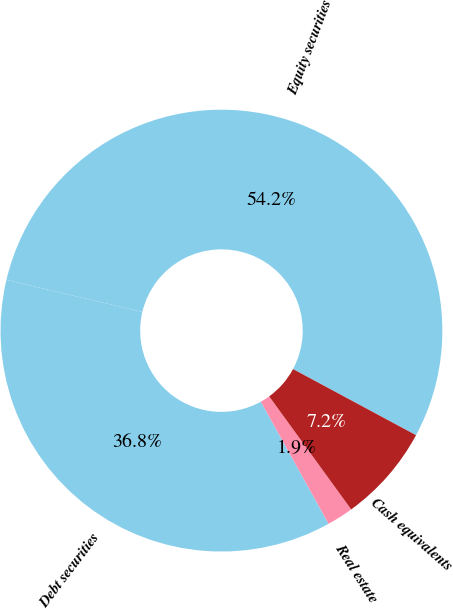Convert chart. <chart><loc_0><loc_0><loc_500><loc_500><pie_chart><fcel>Equity securities<fcel>Debt securities<fcel>Real estate<fcel>Cash equivalents<nl><fcel>54.16%<fcel>36.75%<fcel>1.93%<fcel>7.16%<nl></chart> 